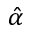<formula> <loc_0><loc_0><loc_500><loc_500>\hat { \alpha }</formula> 